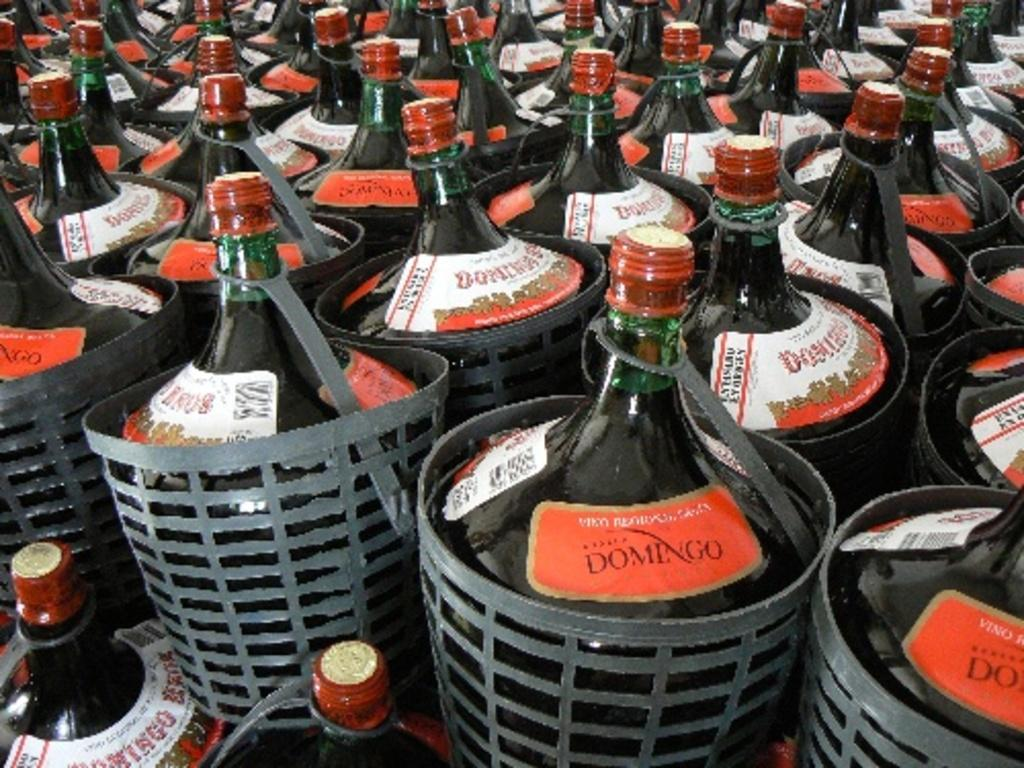Provide a one-sentence caption for the provided image. The bottles are filled with a drink called Domingo. 